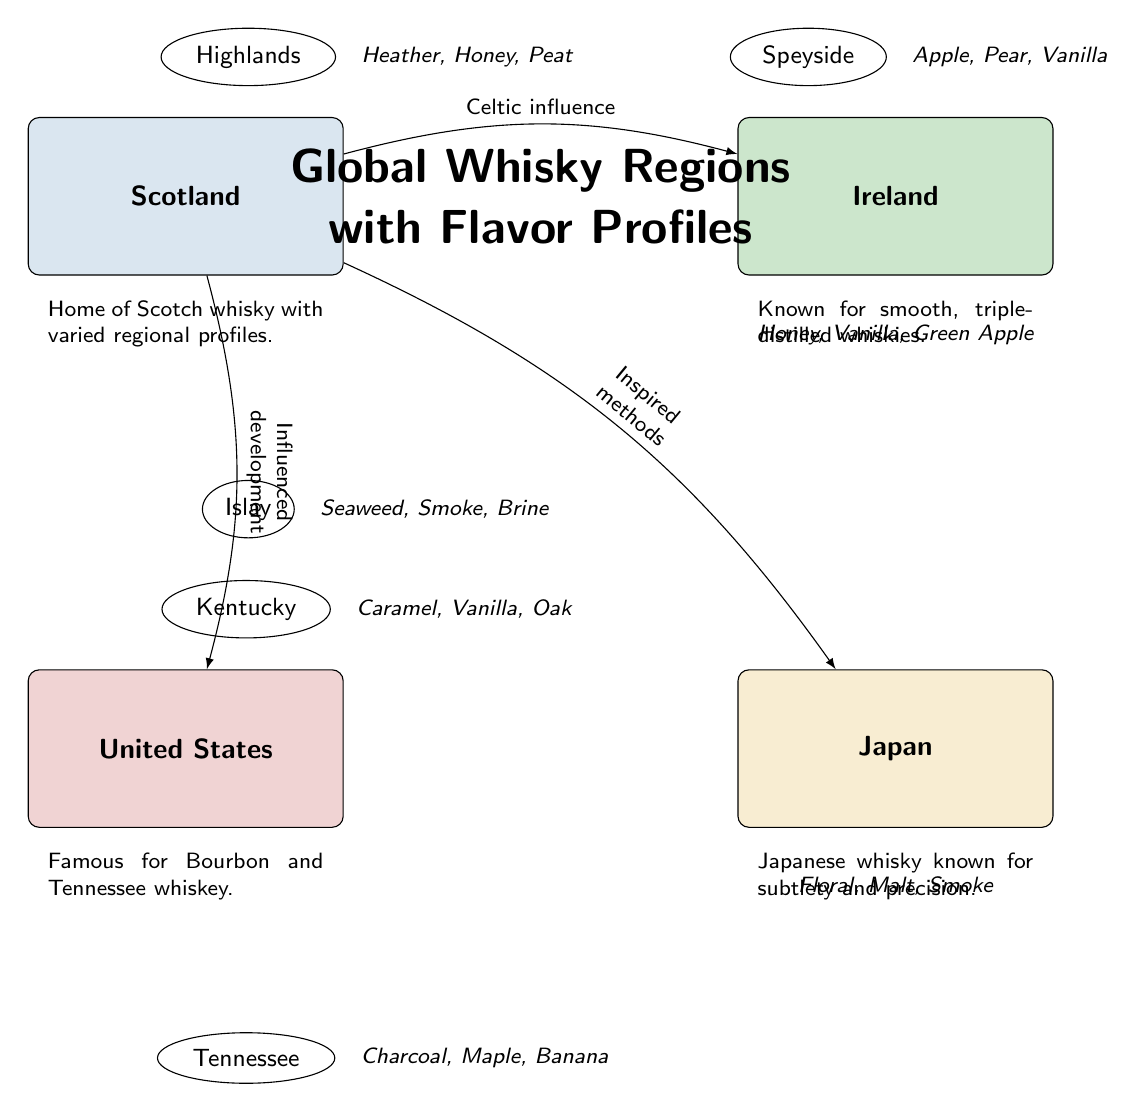What are the whisky flavor profiles from the Islay region? The diagram lists the flavor profiles associated with the Islay region as Seaweed, Smoke, and Brine. These flavor characteristics are specifically connected to this region of whisky production.
Answer: Seaweed, Smoke, Brine How many regions are shown in the diagram? By counting the distinct regions displayed, such as Highlands, Speyside, Islay, Kentucky, Tennessee, and Japan, we find a total of five whisky regions represented in the diagram.
Answer: 5 Which country is known for Bourbon and Tennessee whiskey? According to the diagram, the country associated with Bourbon and Tennessee whiskey is the United States, as it specifically mentions these types of whisky under the United States node.
Answer: United States What flavors are characteristic of the Speyside region? The diagram indicates that the Speyside region has flavor profiles of Apple, Pear, and Vanilla, which define the unique characteristics of whiskies produced in that area.
Answer: Apple, Pear, Vanilla Which country has the influence of Celtic culture? The diagram notes that there is a Celtic influence on whisky production from Scotland, suggesting that this country is closely tied to Celtic heritage within the global whisky landscape.
Answer: Scotland What flavor profiles are associated with Japanese whisky? The diagram identifies the flavor profiles linked to Japanese whisky as Floral, Malt, and Smoke, emphasizing the distinctiveness of whiskies produced in Japan.
Answer: Floral, Malt, Smoke How does the Scotland region influence the United States? The diagram illustrates that Scotland influenced the development of whisky in the United States, reflecting the historical and cultural exchange between these two regions.
Answer: Influenced development Which whisky region is known for smooth, triple-distilled whiskies? Ireland is noted in the diagram for being known for smooth, triple-distilled whiskies, highlighting its specific production techniques that differentiate it from other regions.
Answer: Ireland What type of relationship exists between Scotland and Japan in whisky production? The diagram shows that Scotland inspired methods of whisky production in Japan, indicating a motivational and cultural link between these two regions in terms of whisky-making practices.
Answer: Inspired methods 